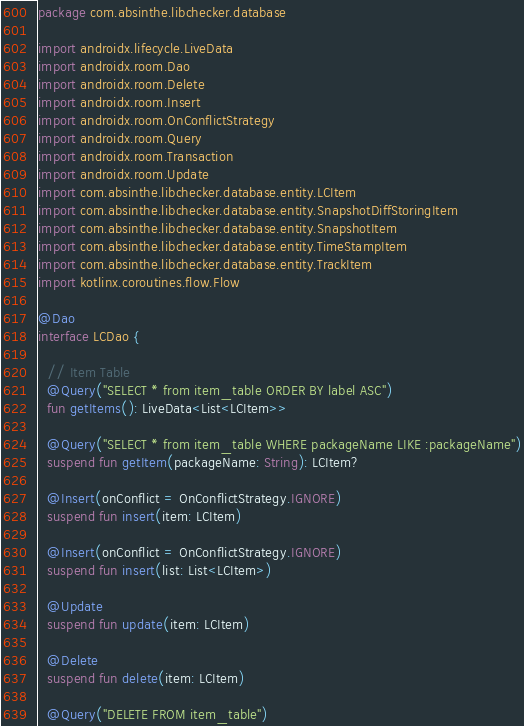Convert code to text. <code><loc_0><loc_0><loc_500><loc_500><_Kotlin_>package com.absinthe.libchecker.database

import androidx.lifecycle.LiveData
import androidx.room.Dao
import androidx.room.Delete
import androidx.room.Insert
import androidx.room.OnConflictStrategy
import androidx.room.Query
import androidx.room.Transaction
import androidx.room.Update
import com.absinthe.libchecker.database.entity.LCItem
import com.absinthe.libchecker.database.entity.SnapshotDiffStoringItem
import com.absinthe.libchecker.database.entity.SnapshotItem
import com.absinthe.libchecker.database.entity.TimeStampItem
import com.absinthe.libchecker.database.entity.TrackItem
import kotlinx.coroutines.flow.Flow

@Dao
interface LCDao {

  // Item Table
  @Query("SELECT * from item_table ORDER BY label ASC")
  fun getItems(): LiveData<List<LCItem>>

  @Query("SELECT * from item_table WHERE packageName LIKE :packageName")
  suspend fun getItem(packageName: String): LCItem?

  @Insert(onConflict = OnConflictStrategy.IGNORE)
  suspend fun insert(item: LCItem)

  @Insert(onConflict = OnConflictStrategy.IGNORE)
  suspend fun insert(list: List<LCItem>)

  @Update
  suspend fun update(item: LCItem)

  @Delete
  suspend fun delete(item: LCItem)

  @Query("DELETE FROM item_table")</code> 